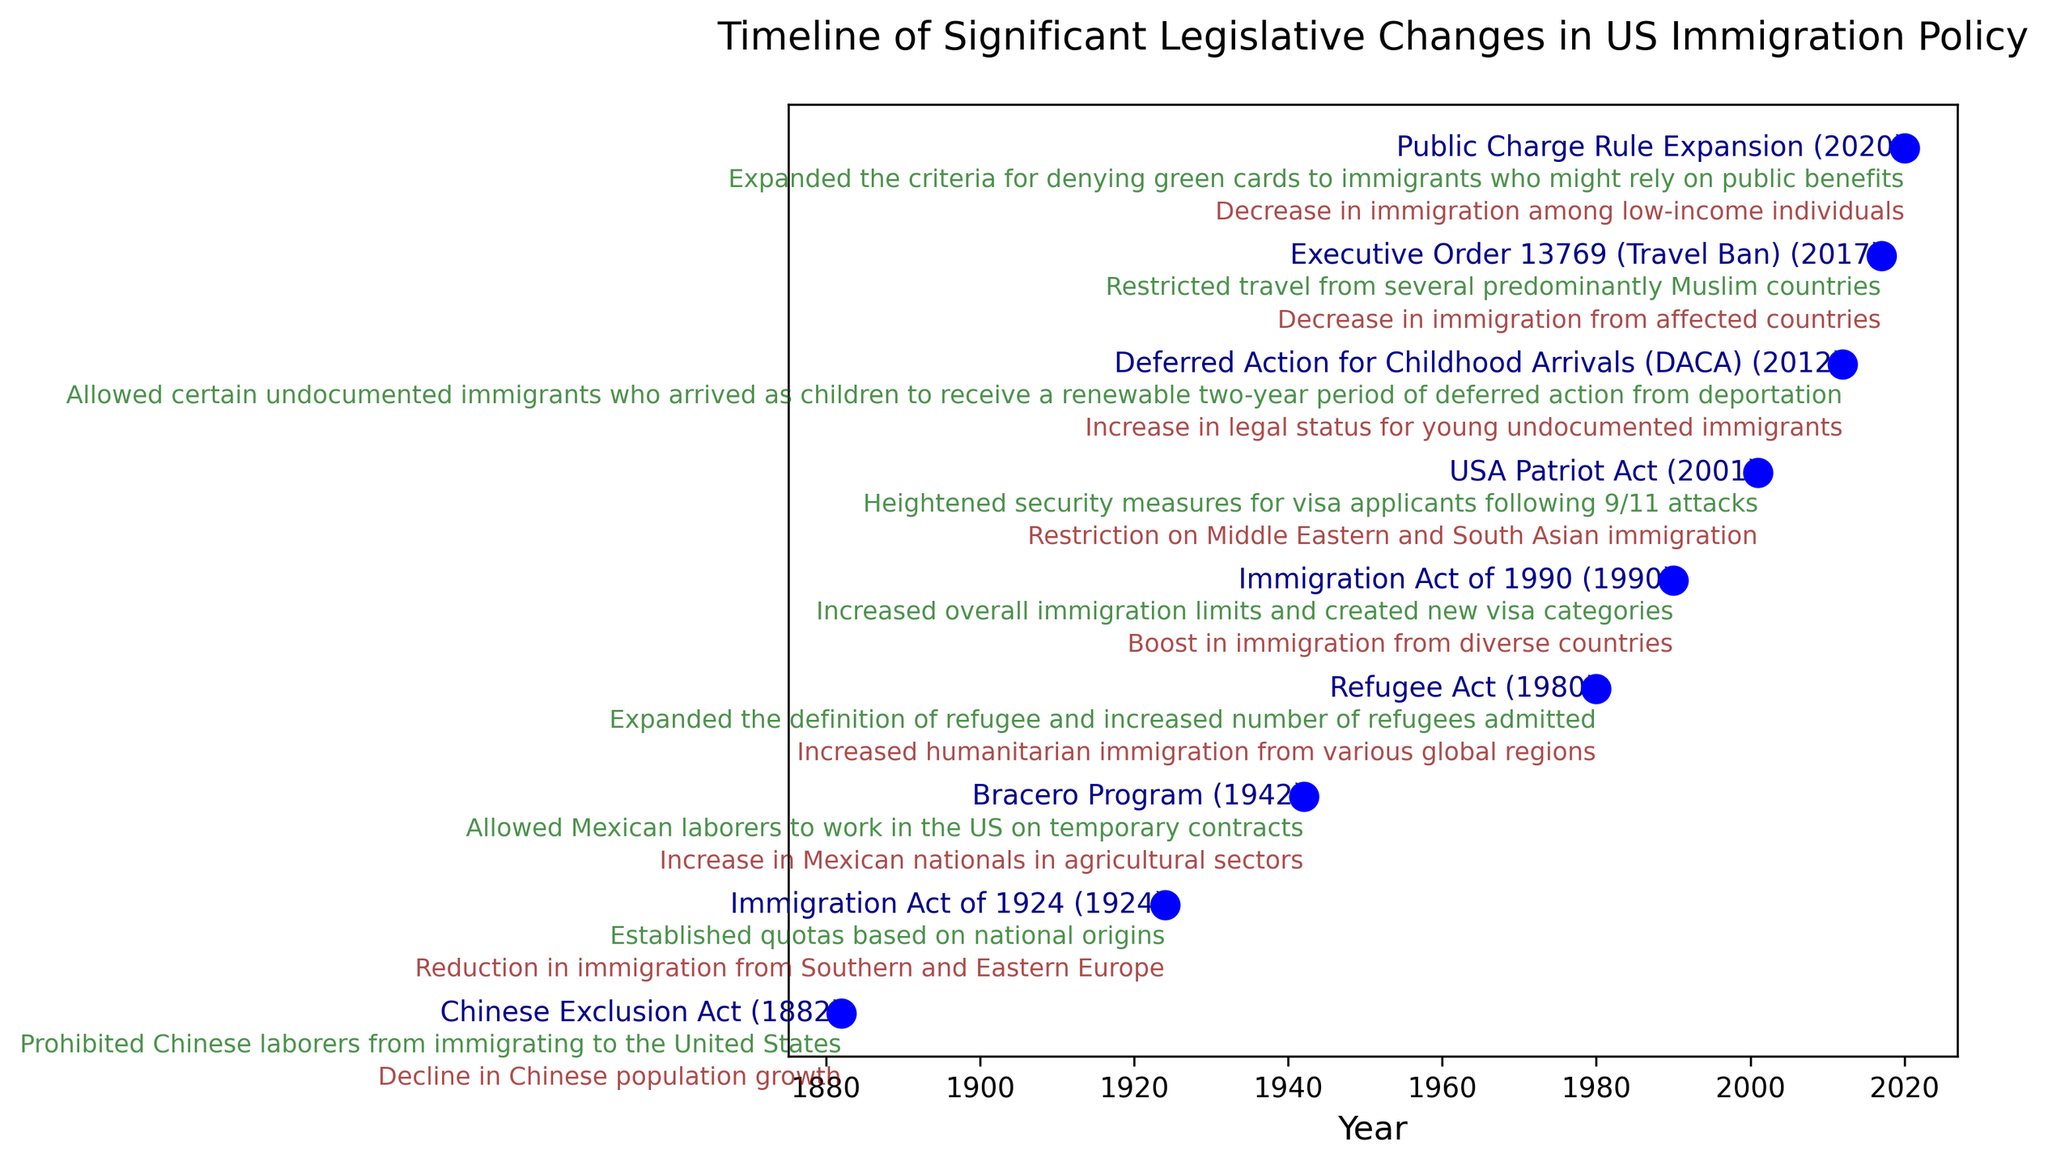What year marks the earliest legislative change in the figure? The earliest year can be identified by looking for the smallest year value on the timeline. The first point on the timeline is for the Chinese Exclusion Act.
Answer: 1882 Which legislation had the most recent impact listed in the timeline? To find the most recent impact, look for the largest year on the timeline. The most recent point on the timeline is for the Public Charge Rule Expansion.
Answer: 2020 Comparing the Chinese Exclusion Act and the Immigration Act of 1924, which one had a broader impact on demographics? Refer to the descriptions and impacts given next to each legislation. The Chinese Exclusion Act caused a decline in Chinese population growth, while the Immigration Act of 1924 reduced immigration from Southern and Eastern Europe. The Immigration Act had a broader regional impact covering multiple countries.
Answer: Immigration Act of 1924 Calculate the average year in which the legislations took place. First, add all the years together: 1882 + 1924 + 1942 + 1980 + 1990 + 2001 + 2012 + 2017 + 2020 = 14768. Then divide by the number of legislations (9): 14768 / 9 ≈ 1641.11.
Answer: 1641.11 Which legislation directly targeted a specific ethnic group? Look at the descriptions and impacts for any mention of ethnic or national groups. The Chinese Exclusion Act specifically targeted Chinese laborers.
Answer: Chinese Exclusion Act Identify the legislation that mentions heightened security measures following a historic event. Examine the descriptions for any reference to security measures and historic events. The USA Patriot Act mentions heightened security measures following 9/11 attacks.
Answer: USA Patriot Act Among the legislations listed, which one had an impact on the legal status of young undocumented immigrants? Read the descriptions and impacts to identify any phrases related to legal status and young immigrants. The Deferred Action for Childhood Arrivals (DACA) had this impact.
Answer: Deferred Action for Childhood Arrivals (DACA) How does the impact of the Bracero Program differ from the Public Charge Rule Expansion? The Bracero Program increased the number of Mexican laborers working in US agricultural sectors, whereas the Public Charge Rule Expansion decreased immigration among low-income individuals. These impacts are opposite in nature, one increasing and the other decreasing immigration.
Answer: One increases, the other decreases 